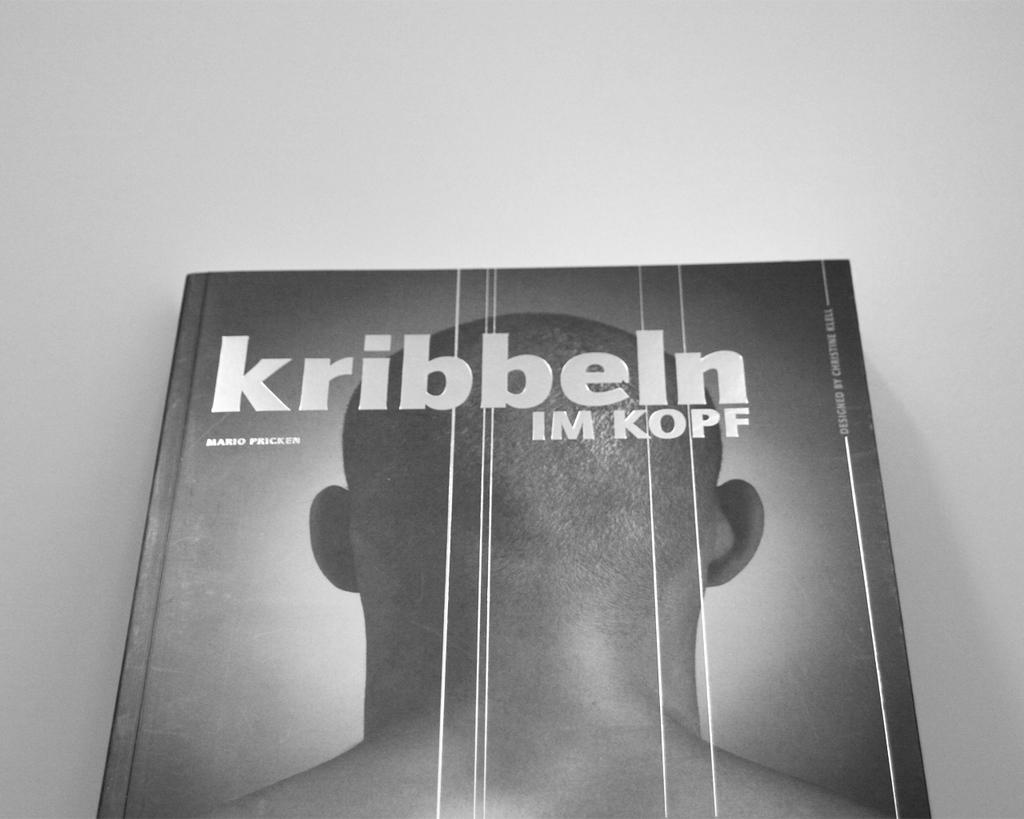<image>
Create a compact narrative representing the image presented. A book titled Kribbeln Im Kopf features the back of a bald head. 